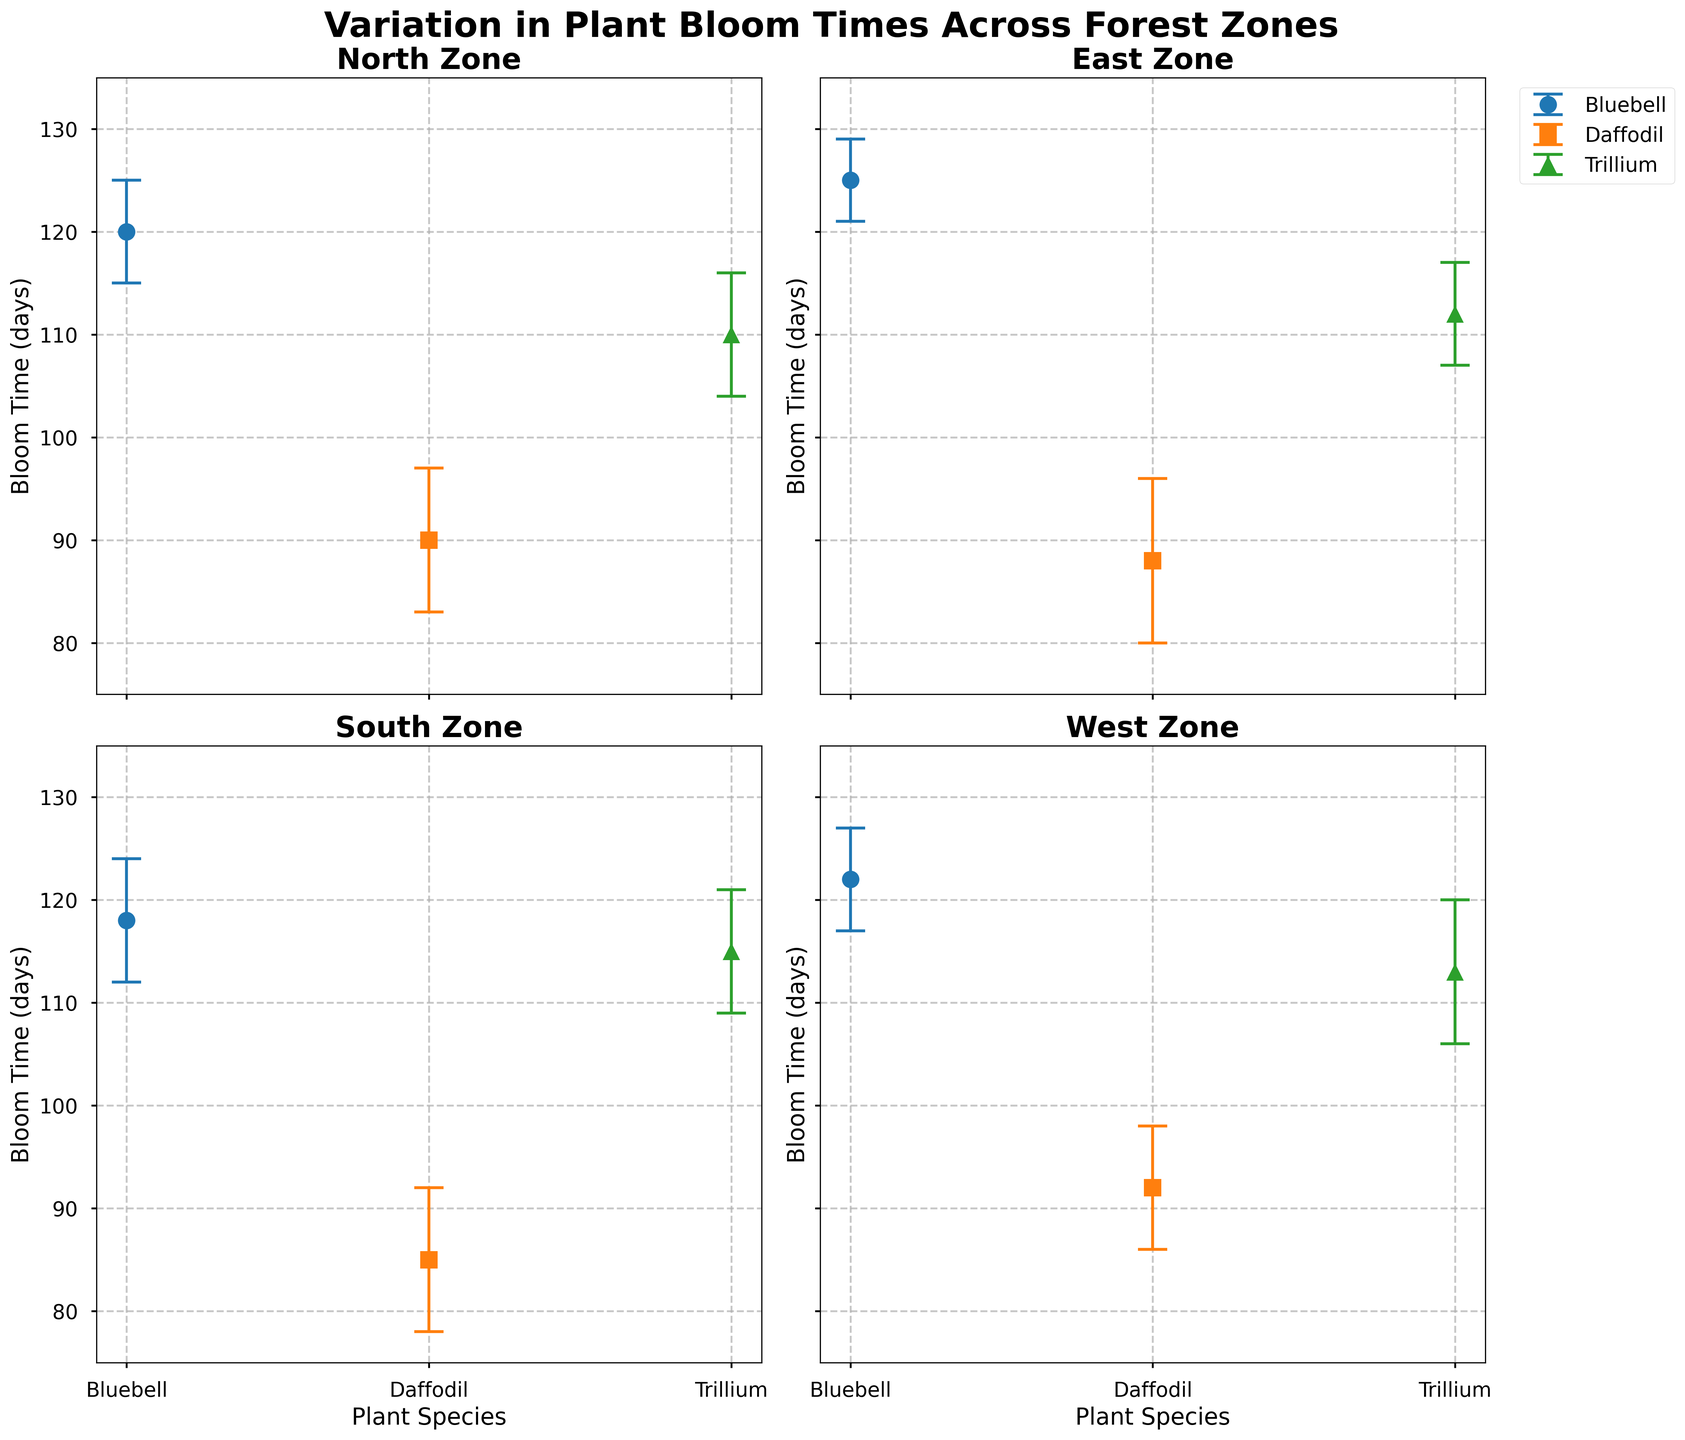How many zones are illustrated in the figure? There are four subplots, each labeled with a different zone: North Zone, East Zone, South Zone, and West Zone. Thus, there are four zones illustrated.
Answer: Four What is the mean bloom time of Bluebell in the East Zone? The subplot titled "East Zone" shows the mean bloom time for Bluebell with an error bar. By examining this subplot, the mean bloom time for Bluebell is located close to the data point, which indicates 125 days.
Answer: 125 days Which species has the highest variation in bloom time in the North Zone? In the subplot titled "North Zone," the species with the highest standard deviation can be identified by the length of the error bars. Daffodil has the longest error bar, signifying the highest variation.
Answer: Daffodil Compare the mean bloom time of Trillium between the South Zone and the West Zone. Which one has a higher mean bloom time? By looking at the subplots titled "South Zone" and "West Zone," the mean bloom times for Trillium are noted. In the South Zone, it is 115 days, and in the West Zone, it is 113 days. Therefore, the South Zone has a higher mean bloom time for Trillium.
Answer: South Zone What is the average mean bloom time of Daffodil across all zones? Retrieve the mean bloom times for Daffodil in each zone: North (90), East (88), South (85), and West (92). Calculate the average as follows: (90 + 88 + 85 + 92) / 4 = 88.75 days.
Answer: 88.75 days Which zone shows the smallest variation in the bloom time of Bluebell? Examine the standard deviations (the length of error bars) for Bluebell in all zones: North (5), East (4), South (6), and West (5). The smallest error bar belongs to the East Zone, meaning it has the smallest variation.
Answer: East Zone How does the mean bloom time of Daffodils compare between the North and South Zones? In the figure, the mean bloom time for Daffodils in the North Zone is shown as 90 days, while in the South Zone, it is 85 days. Therefore, North Zone has a longer mean bloom time compared to the South Zone.
Answer: North Zone has a longer mean bloom time What is the total range of mean bloom times for Bluebells across all zones? Find the minimum and maximum mean bloom times for Bluebells: East (125), South (118), North (120), and West (122). The total range is calculated as the difference between the maximum and minimum values: 125 - 118 = 7 days.
Answer: 7 days How does the variation in bloom time of Trillium in the West Zone compare to that in the East Zone? In the West Zone, the standard deviation (length of the error bar) for Trillium is 7 days, while in the East Zone it is 5 days. The West Zone has a larger variation in bloom time for Trillium than the East Zone.
Answer: West Zone has larger variation 